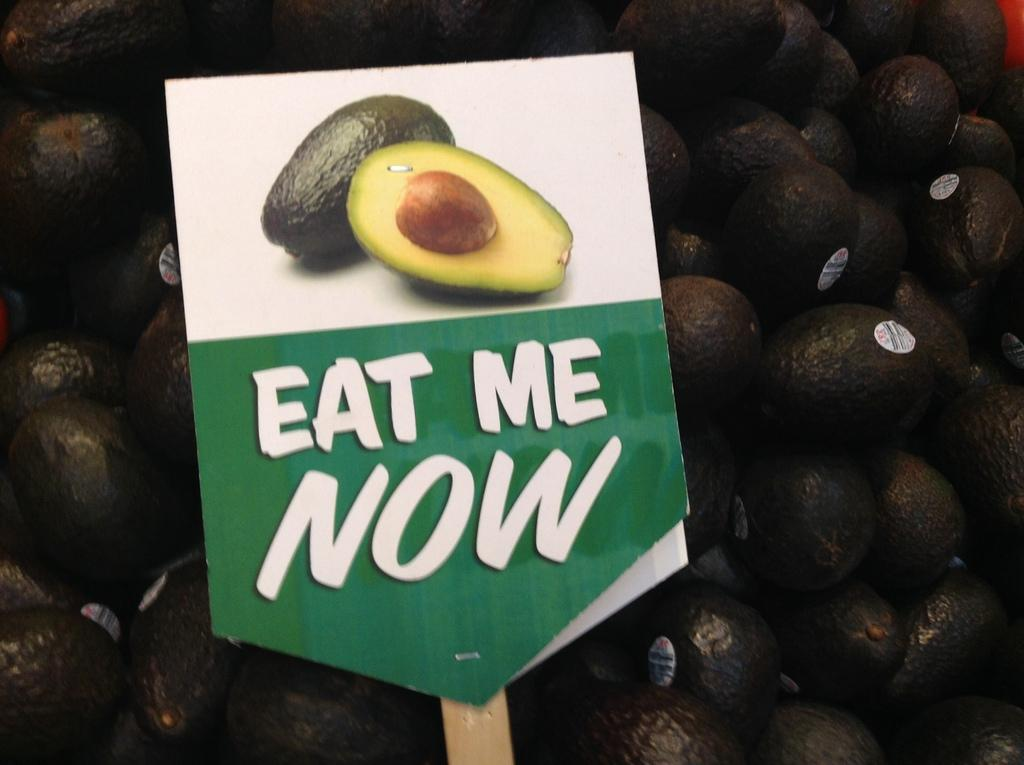What is located in the foreground of the image? There is a board in the foreground of the image. What is depicted on the board? There is a fruit depicted on the board. What else can be seen on the board? There is text on the board. What is the main subject in the center of the image? There are avocados in the center of the image. Can you see any dirt on the cactus in the image? There is no cactus present in the image, so it is not possible to determine if there is any dirt on it. 